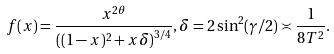<formula> <loc_0><loc_0><loc_500><loc_500>f ( x ) = \frac { x ^ { 2 \theta } } { \left ( ( 1 - x ) ^ { 2 } + x \delta \right ) ^ { 3 / 4 } } , \delta = 2 \sin ^ { 2 } ( \gamma / 2 ) \asymp \frac { 1 } { 8 T ^ { 2 } } .</formula> 